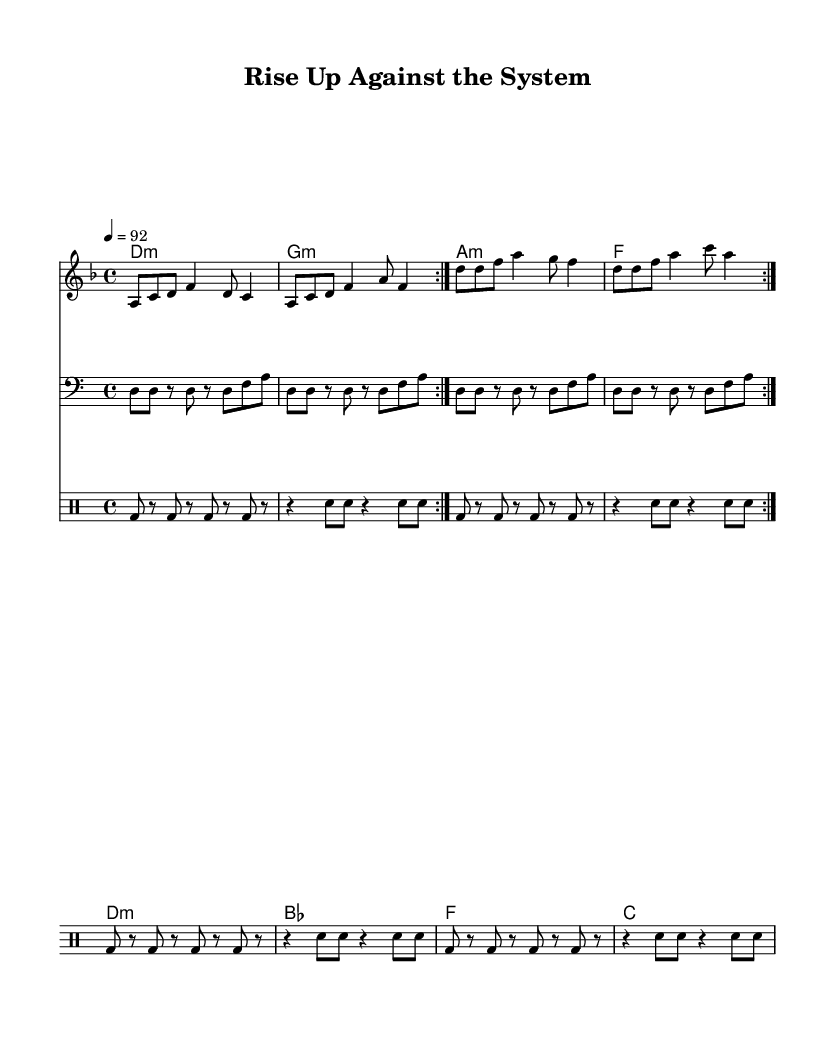What is the key signature of this music? The key signature is D minor, which has one flat (B flat). This can be determined by looking at the key signature indicated at the beginning of the score.
Answer: D minor What is the time signature of the piece? The time signature is 4/4, which can be found at the beginning of the sheet music and indicates that there are four beats in each measure.
Answer: 4/4 What is the tempo marking for this song? The tempo marking is 92 BPM, as indicated in the tempo section of the global settings. This means the piece should be played at a speed of 92 beats per minute.
Answer: 92 How many measures are in the repeated section of the melody? There are 8 measures in the repeated section (2 times 4 measures). This can be confirmed by counting the measures in the melody part that are repeated.
Answer: 8 How many times is the chorus sung in the song? The chorus is sung once according to the lyrical layout that follows after the verse section, which is indicated by the structure of the lyrics in the score.
Answer: 1 What is the bass clef note that starts the bass line? The bass line starts with the note D, which is indicated at the beginning of the bass line in the score.
Answer: D What lyrical theme does the chorus address? The chorus addresses themes of justice and equality, which is evident from the lyrics provided for that section, specifically the phrases "Fight for justice, equality" and "Tear down walls of brutality."
Answer: Justice and equality 